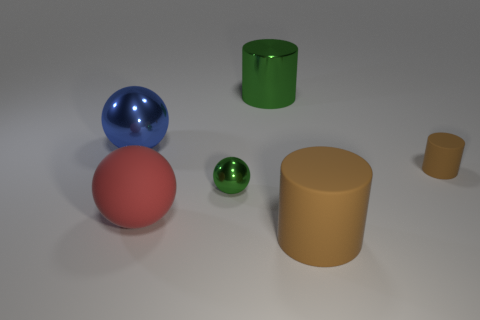Do the small sphere and the cylinder on the left side of the big brown rubber cylinder have the same color? yes 